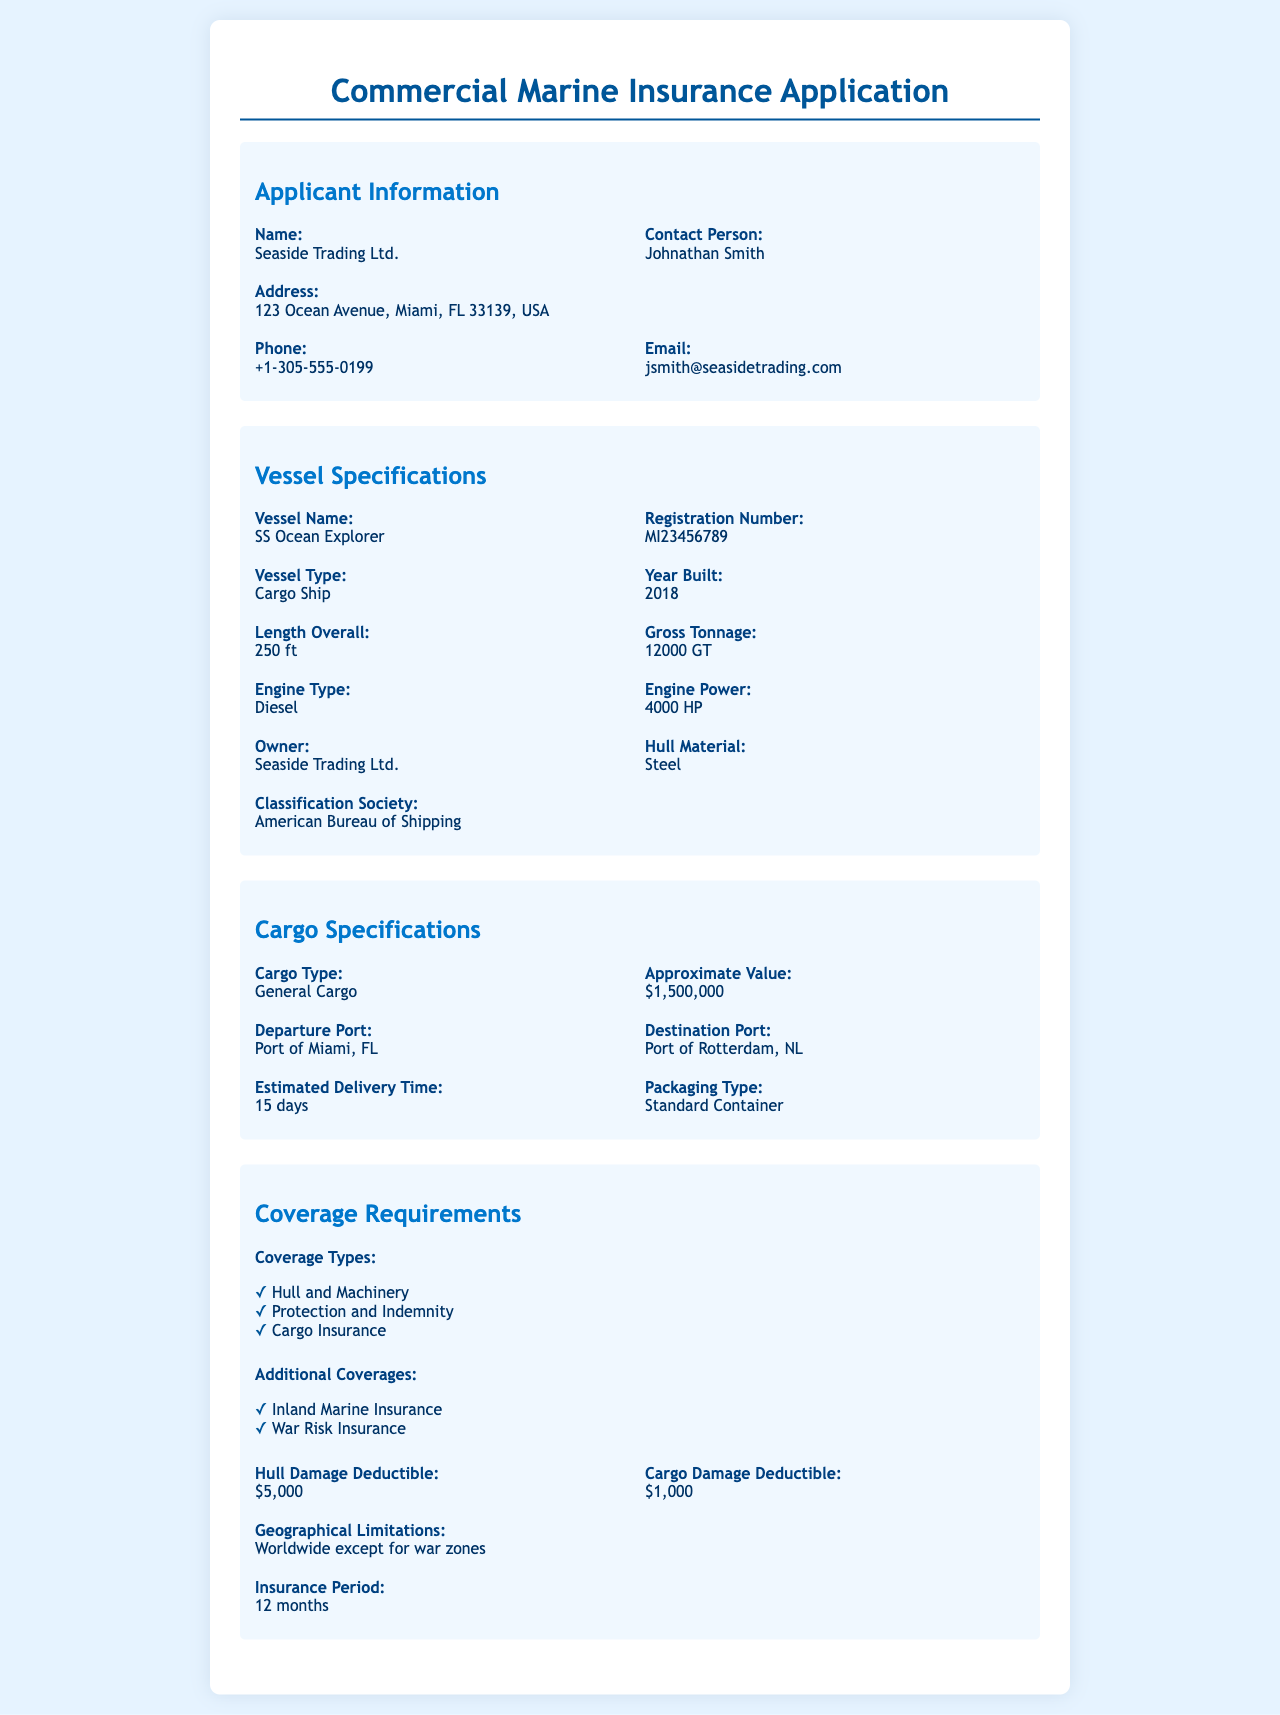What is the name of the applicant? The name of the applicant is provided in the document, which is "Seaside Trading Ltd."
Answer: Seaside Trading Ltd Who is the contact person? The contact person is specified in the applicant information section, which states "Johnathan Smith."
Answer: Johnathan Smith What is the vessel type? The vessel type is detailed under vessel specifications and is identified as "Cargo Ship."
Answer: Cargo Ship What is the approximate value of the cargo? The approximate value can be found in the cargo specifications and is "$1,500,000."
Answer: $1,500,000 What is the hull damage deductible? The hull damage deductible is noted in the coverage requirements, which states it is "$5,000."
Answer: $5,000 What is the insurance period? The insurance period is given among the coverage requirements, which indicates "12 months."
Answer: 12 months How long is the estimated delivery time? The estimated delivery time can be found in the cargo specifications and is "15 days."
Answer: 15 days What is the geographical limitation for coverage? The geographical limitations are outlined in the coverage requirements, stating "Worldwide except for war zones."
Answer: Worldwide except for war zones What type of vessel is managed by the applicant? The type of vessel is included in the vessel specifications, specifically as "SS Ocean Explorer."
Answer: SS Ocean Explorer 